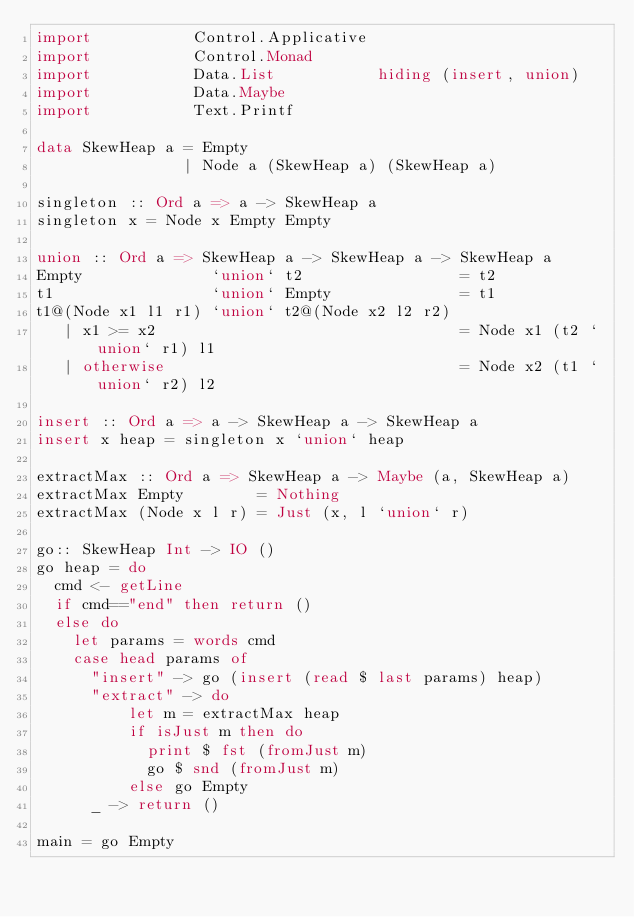<code> <loc_0><loc_0><loc_500><loc_500><_Haskell_>import           Control.Applicative
import           Control.Monad
import           Data.List           hiding (insert, union)
import           Data.Maybe
import           Text.Printf

data SkewHeap a = Empty
                | Node a (SkewHeap a) (SkewHeap a)

singleton :: Ord a => a -> SkewHeap a
singleton x = Node x Empty Empty

union :: Ord a => SkewHeap a -> SkewHeap a -> SkewHeap a
Empty              `union` t2                 = t2
t1                 `union` Empty              = t1
t1@(Node x1 l1 r1) `union` t2@(Node x2 l2 r2)
   | x1 >= x2                                 = Node x1 (t2 `union` r1) l1
   | otherwise                                = Node x2 (t1 `union` r2) l2

insert :: Ord a => a -> SkewHeap a -> SkewHeap a
insert x heap = singleton x `union` heap

extractMax :: Ord a => SkewHeap a -> Maybe (a, SkewHeap a)
extractMax Empty        = Nothing
extractMax (Node x l r) = Just (x, l `union` r)

go:: SkewHeap Int -> IO ()
go heap = do
  cmd <- getLine
  if cmd=="end" then return ()
  else do
    let params = words cmd
    case head params of
      "insert" -> go (insert (read $ last params) heap)
      "extract" -> do
          let m = extractMax heap
          if isJust m then do
            print $ fst (fromJust m)
            go $ snd (fromJust m)
          else go Empty
      _ -> return ()

main = go Empty
</code> 